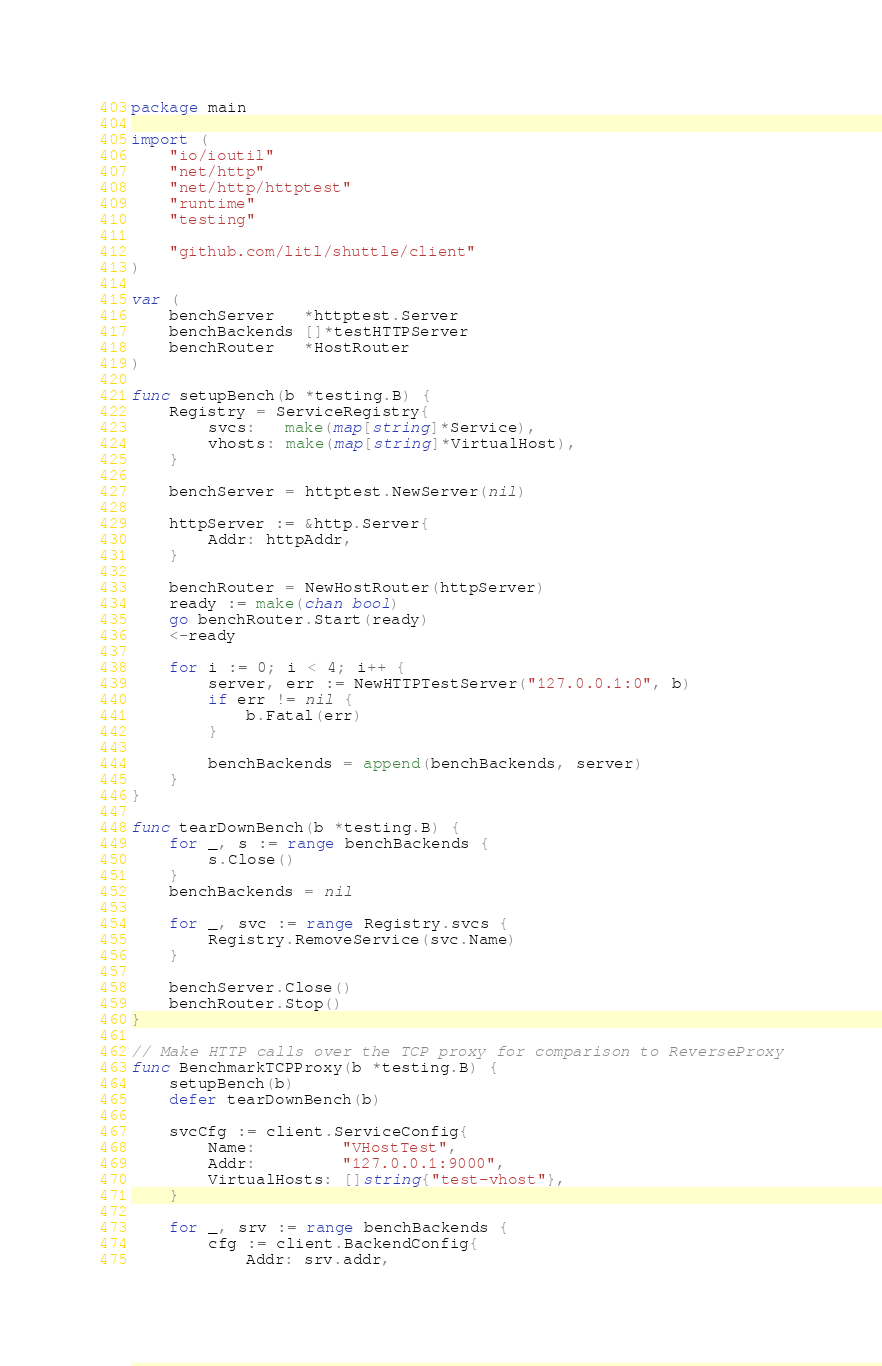<code> <loc_0><loc_0><loc_500><loc_500><_Go_>package main

import (
	"io/ioutil"
	"net/http"
	"net/http/httptest"
	"runtime"
	"testing"

	"github.com/litl/shuttle/client"
)

var (
	benchServer   *httptest.Server
	benchBackends []*testHTTPServer
	benchRouter   *HostRouter
)

func setupBench(b *testing.B) {
	Registry = ServiceRegistry{
		svcs:   make(map[string]*Service),
		vhosts: make(map[string]*VirtualHost),
	}

	benchServer = httptest.NewServer(nil)

	httpServer := &http.Server{
		Addr: httpAddr,
	}

	benchRouter = NewHostRouter(httpServer)
	ready := make(chan bool)
	go benchRouter.Start(ready)
	<-ready

	for i := 0; i < 4; i++ {
		server, err := NewHTTPTestServer("127.0.0.1:0", b)
		if err != nil {
			b.Fatal(err)
		}

		benchBackends = append(benchBackends, server)
	}
}

func tearDownBench(b *testing.B) {
	for _, s := range benchBackends {
		s.Close()
	}
	benchBackends = nil

	for _, svc := range Registry.svcs {
		Registry.RemoveService(svc.Name)
	}

	benchServer.Close()
	benchRouter.Stop()
}

// Make HTTP calls over the TCP proxy for comparison to ReverseProxy
func BenchmarkTCPProxy(b *testing.B) {
	setupBench(b)
	defer tearDownBench(b)

	svcCfg := client.ServiceConfig{
		Name:         "VHostTest",
		Addr:         "127.0.0.1:9000",
		VirtualHosts: []string{"test-vhost"},
	}

	for _, srv := range benchBackends {
		cfg := client.BackendConfig{
			Addr: srv.addr,</code> 